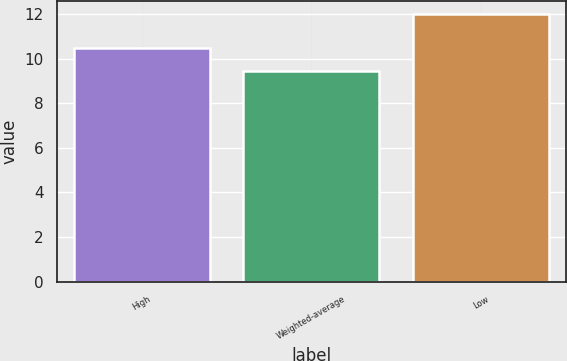Convert chart to OTSL. <chart><loc_0><loc_0><loc_500><loc_500><bar_chart><fcel>High<fcel>Weighted-average<fcel>Low<nl><fcel>10.5<fcel>9.47<fcel>12<nl></chart> 